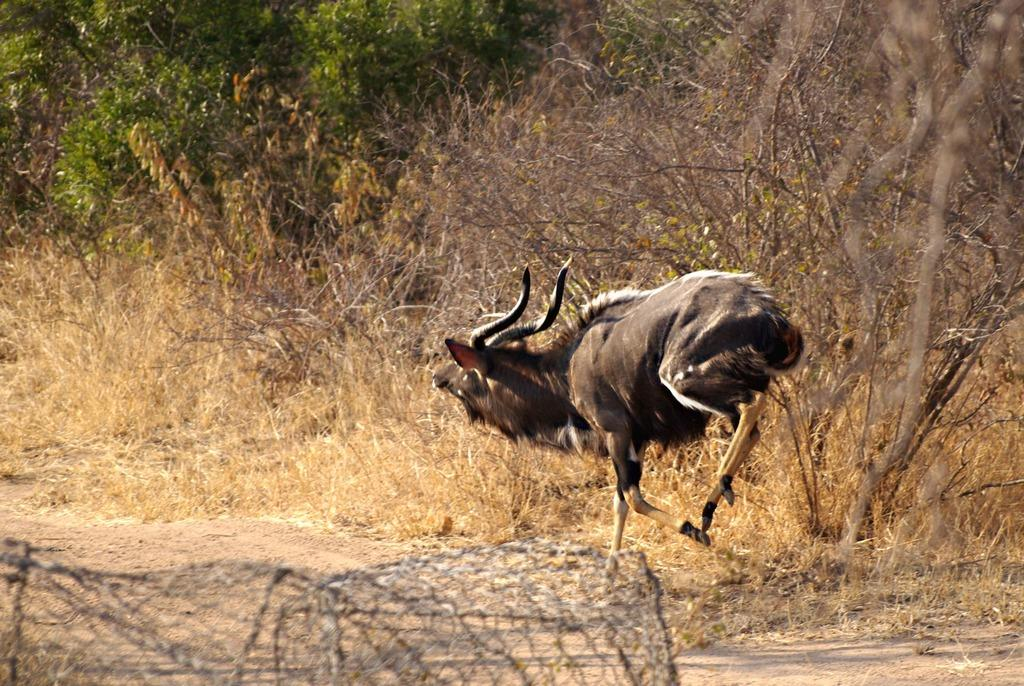What is the animal doing in the image? The animal is running on the road in the image. What type of vegetation can be seen in the image? There are trees, bushes, and grass in the image. What is present on the surface in the image? There is an object on the surface in the image. What color is the crayon that the animal is holding in the image? There is no crayon present in the image, and the animal is not holding anything. Is the animal wearing a collar in the image? There is no collar visible on the animal in the image. 